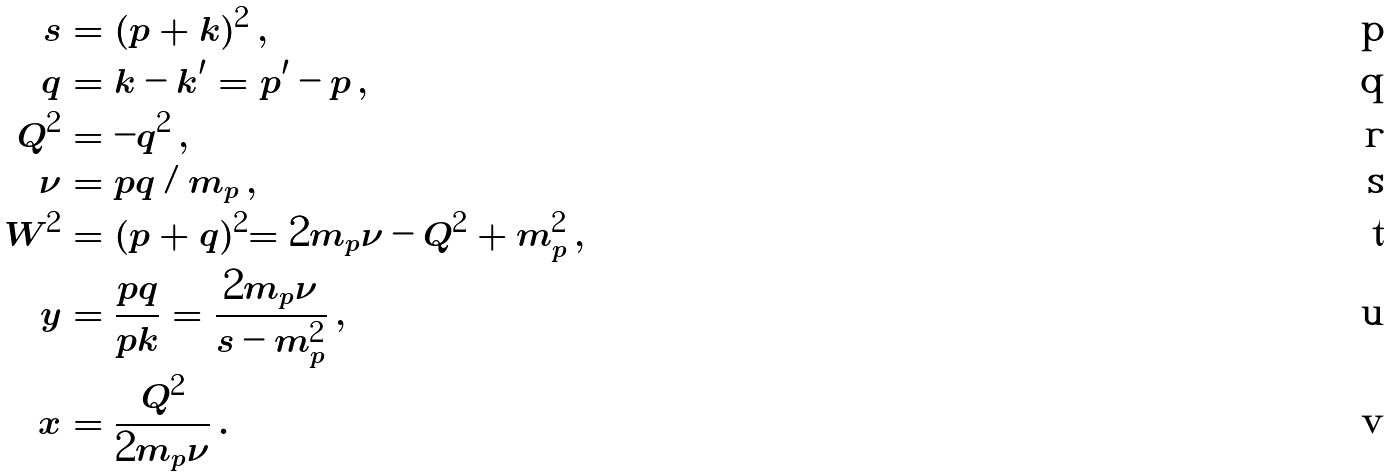<formula> <loc_0><loc_0><loc_500><loc_500>s & = ( p + k ) ^ { 2 } \, , \\ q & = k - k ^ { \prime } = p ^ { \prime } - p \, , \\ Q ^ { 2 } & = - q ^ { 2 } \, , \\ \nu & = p q / m _ { p } \, , \\ W ^ { 2 } & = ( p + q ) ^ { 2 } = 2 m _ { p } \nu - Q ^ { 2 } + m _ { p } ^ { 2 } \, , \\ y & = \frac { p q } { p k } = \frac { 2 m _ { p } \nu } { s - m _ { p } ^ { 2 } } \, , \\ x & = \frac { Q ^ { 2 } } { 2 m _ { p } \nu } \, .</formula> 